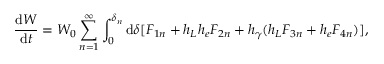Convert formula to latex. <formula><loc_0><loc_0><loc_500><loc_500>\frac { d W } { d t } = W _ { 0 } \sum _ { n = 1 } ^ { \infty } \int _ { 0 } ^ { \delta _ { n } } d \delta [ F _ { 1 n } + h _ { L } h _ { e } F _ { 2 n } + h _ { \gamma } ( h _ { L } F _ { 3 n } + h _ { e } F _ { 4 n } ) ] ,</formula> 